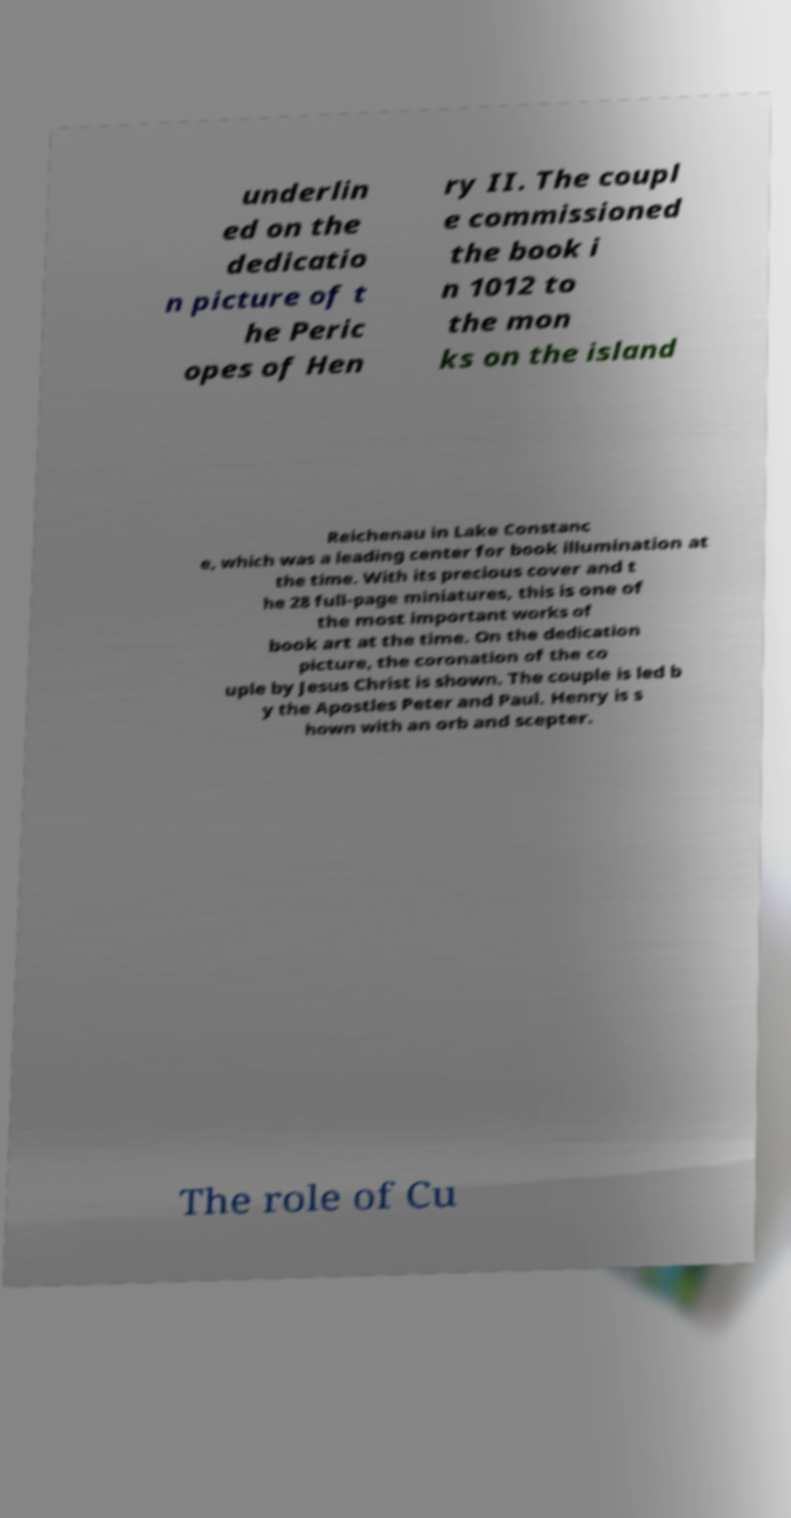For documentation purposes, I need the text within this image transcribed. Could you provide that? underlin ed on the dedicatio n picture of t he Peric opes of Hen ry II. The coupl e commissioned the book i n 1012 to the mon ks on the island Reichenau in Lake Constanc e, which was a leading center for book illumination at the time. With its precious cover and t he 28 full-page miniatures, this is one of the most important works of book art at the time. On the dedication picture, the coronation of the co uple by Jesus Christ is shown. The couple is led b y the Apostles Peter and Paul. Henry is s hown with an orb and scepter. The role of Cu 